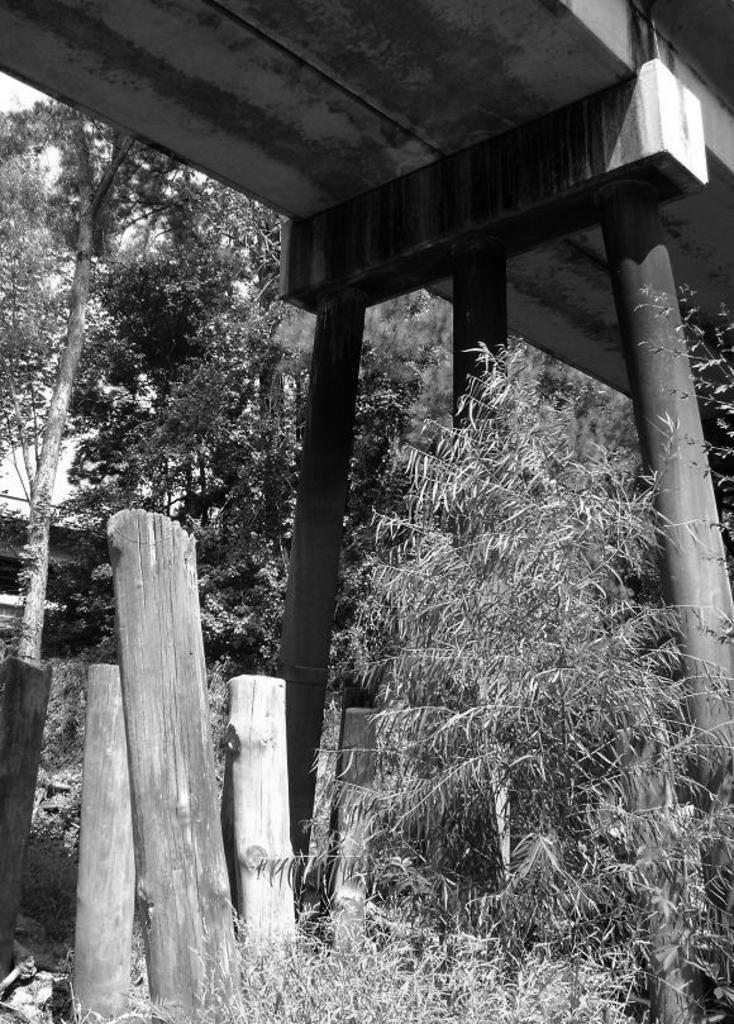What type of picture is in the image? The image contains a black and white picture. What objects can be seen in the picture? There are wooden logs and plants in the image. How many pillars are visible in the image? There are two pillars in the image. What structure can be seen in the image? There is a bridge in the image. What part of the natural environment is visible in the image? The sky is visible in the background of the image. What type of polish is being applied to the butter in the image? There is no butter or polish present in the image. Can you tell me how many animals are visible in the zoo in the image? There is no zoo present in the image. 